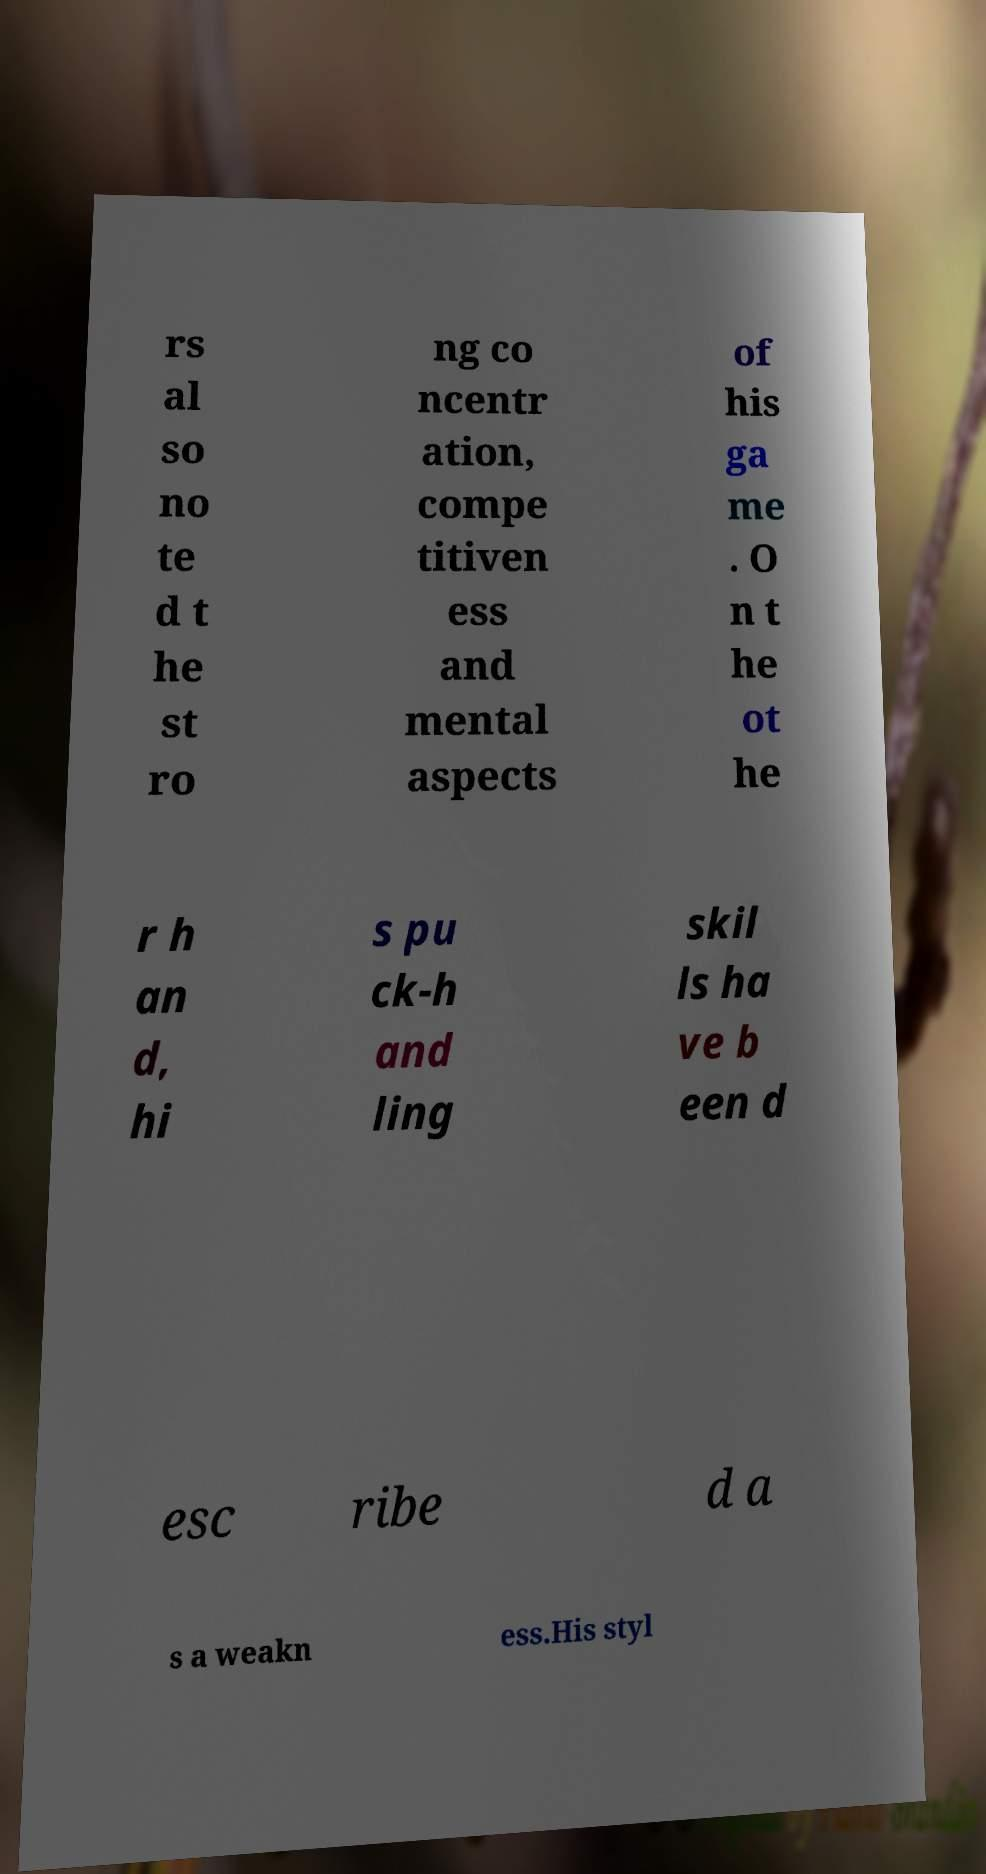I need the written content from this picture converted into text. Can you do that? rs al so no te d t he st ro ng co ncentr ation, compe titiven ess and mental aspects of his ga me . O n t he ot he r h an d, hi s pu ck-h and ling skil ls ha ve b een d esc ribe d a s a weakn ess.His styl 